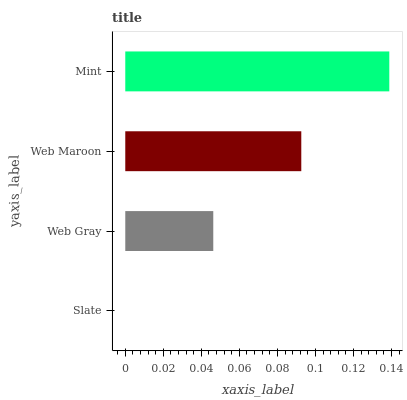Is Slate the minimum?
Answer yes or no. Yes. Is Mint the maximum?
Answer yes or no. Yes. Is Web Gray the minimum?
Answer yes or no. No. Is Web Gray the maximum?
Answer yes or no. No. Is Web Gray greater than Slate?
Answer yes or no. Yes. Is Slate less than Web Gray?
Answer yes or no. Yes. Is Slate greater than Web Gray?
Answer yes or no. No. Is Web Gray less than Slate?
Answer yes or no. No. Is Web Maroon the high median?
Answer yes or no. Yes. Is Web Gray the low median?
Answer yes or no. Yes. Is Slate the high median?
Answer yes or no. No. Is Mint the low median?
Answer yes or no. No. 